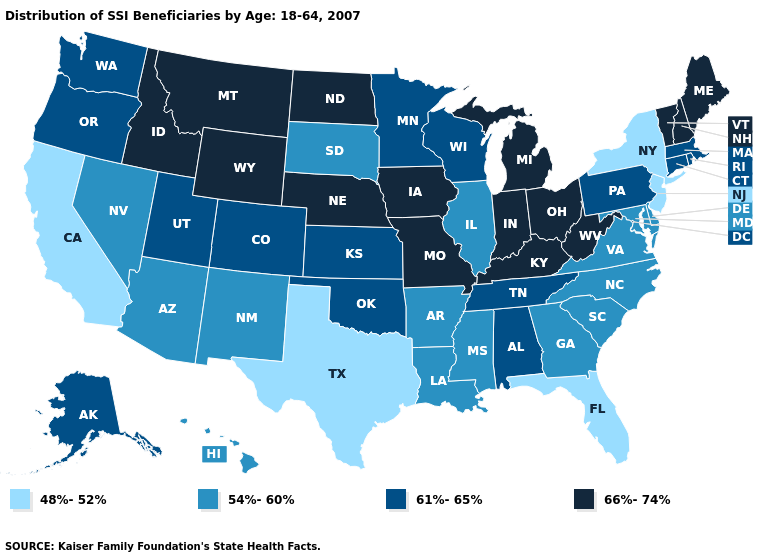What is the lowest value in the USA?
Concise answer only. 48%-52%. How many symbols are there in the legend?
Give a very brief answer. 4. What is the value of Connecticut?
Be succinct. 61%-65%. Name the states that have a value in the range 66%-74%?
Give a very brief answer. Idaho, Indiana, Iowa, Kentucky, Maine, Michigan, Missouri, Montana, Nebraska, New Hampshire, North Dakota, Ohio, Vermont, West Virginia, Wyoming. How many symbols are there in the legend?
Answer briefly. 4. Which states hav the highest value in the West?
Answer briefly. Idaho, Montana, Wyoming. Which states have the lowest value in the USA?
Concise answer only. California, Florida, New Jersey, New York, Texas. Does Maine have a higher value than New Hampshire?
Short answer required. No. Among the states that border California , does Oregon have the highest value?
Concise answer only. Yes. What is the lowest value in states that border South Carolina?
Concise answer only. 54%-60%. Name the states that have a value in the range 48%-52%?
Concise answer only. California, Florida, New Jersey, New York, Texas. What is the highest value in the USA?
Give a very brief answer. 66%-74%. What is the lowest value in states that border Arizona?
Be succinct. 48%-52%. 